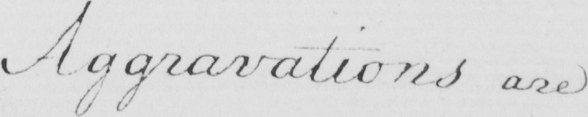Please provide the text content of this handwritten line. Aggravations are 